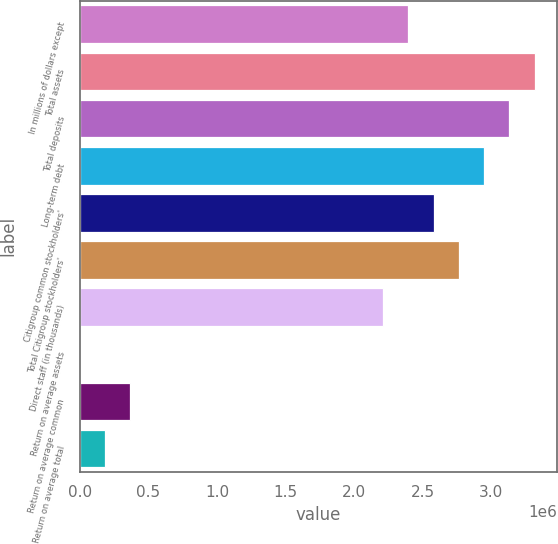Convert chart to OTSL. <chart><loc_0><loc_0><loc_500><loc_500><bar_chart><fcel>In millions of dollars except<fcel>Total assets<fcel>Total deposits<fcel>Long-term debt<fcel>Citigroup common stockholders'<fcel>Total Citigroup stockholders'<fcel>Direct staff (in thousands)<fcel>Return on average assets<fcel>Return on average common<fcel>Return on average total<nl><fcel>2.3952e+06<fcel>3.31644e+06<fcel>3.13219e+06<fcel>2.94794e+06<fcel>2.57945e+06<fcel>2.7637e+06<fcel>2.21096e+06<fcel>0.36<fcel>368493<fcel>184247<nl></chart> 